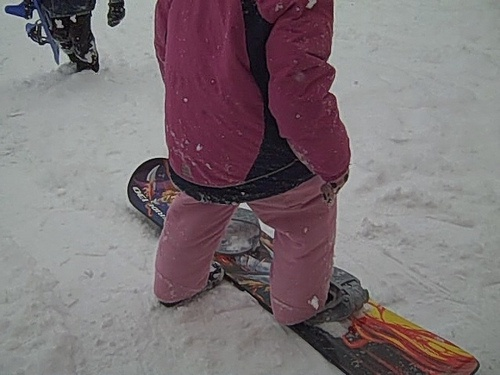Describe the objects in this image and their specific colors. I can see people in darkgray, purple, brown, and black tones, snowboard in darkgray, black, gray, and maroon tones, and snowboard in darkgray, gray, black, and darkblue tones in this image. 